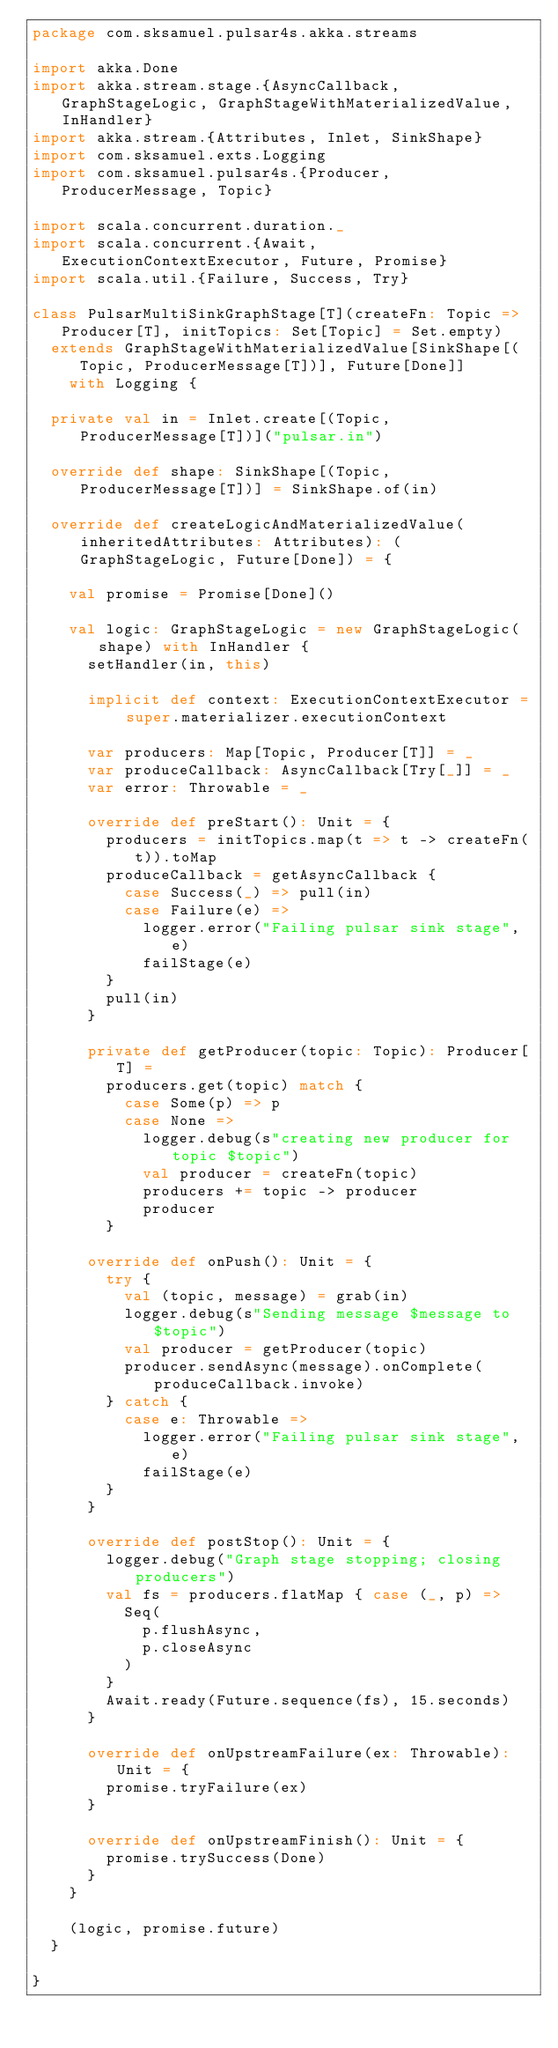Convert code to text. <code><loc_0><loc_0><loc_500><loc_500><_Scala_>package com.sksamuel.pulsar4s.akka.streams

import akka.Done
import akka.stream.stage.{AsyncCallback, GraphStageLogic, GraphStageWithMaterializedValue, InHandler}
import akka.stream.{Attributes, Inlet, SinkShape}
import com.sksamuel.exts.Logging
import com.sksamuel.pulsar4s.{Producer, ProducerMessage, Topic}

import scala.concurrent.duration._
import scala.concurrent.{Await, ExecutionContextExecutor, Future, Promise}
import scala.util.{Failure, Success, Try}

class PulsarMultiSinkGraphStage[T](createFn: Topic => Producer[T], initTopics: Set[Topic] = Set.empty)
  extends GraphStageWithMaterializedValue[SinkShape[(Topic, ProducerMessage[T])], Future[Done]]
    with Logging {

  private val in = Inlet.create[(Topic, ProducerMessage[T])]("pulsar.in")

  override def shape: SinkShape[(Topic, ProducerMessage[T])] = SinkShape.of(in)

  override def createLogicAndMaterializedValue(inheritedAttributes: Attributes): (GraphStageLogic, Future[Done]) = {

    val promise = Promise[Done]()

    val logic: GraphStageLogic = new GraphStageLogic(shape) with InHandler {
      setHandler(in, this)

      implicit def context: ExecutionContextExecutor = super.materializer.executionContext

      var producers: Map[Topic, Producer[T]] = _
      var produceCallback: AsyncCallback[Try[_]] = _
      var error: Throwable = _

      override def preStart(): Unit = {
        producers = initTopics.map(t => t -> createFn(t)).toMap
        produceCallback = getAsyncCallback {
          case Success(_) => pull(in)
          case Failure(e) =>
            logger.error("Failing pulsar sink stage", e)
            failStage(e)
        }
        pull(in)
      }

      private def getProducer(topic: Topic): Producer[T] =
        producers.get(topic) match {
          case Some(p) => p
          case None =>
            logger.debug(s"creating new producer for topic $topic")
            val producer = createFn(topic)
            producers += topic -> producer
            producer
        }

      override def onPush(): Unit = {
        try {
          val (topic, message) = grab(in)
          logger.debug(s"Sending message $message to $topic")
          val producer = getProducer(topic)
          producer.sendAsync(message).onComplete(produceCallback.invoke)
        } catch {
          case e: Throwable =>
            logger.error("Failing pulsar sink stage", e)
            failStage(e)
        }
      }

      override def postStop(): Unit = {
        logger.debug("Graph stage stopping; closing producers")
        val fs = producers.flatMap { case (_, p) =>
          Seq(
            p.flushAsync,
            p.closeAsync
          )
        }
        Await.ready(Future.sequence(fs), 15.seconds)
      }

      override def onUpstreamFailure(ex: Throwable): Unit = {
        promise.tryFailure(ex)
      }

      override def onUpstreamFinish(): Unit = {
        promise.trySuccess(Done)
      }
    }

    (logic, promise.future)
  }

}
</code> 